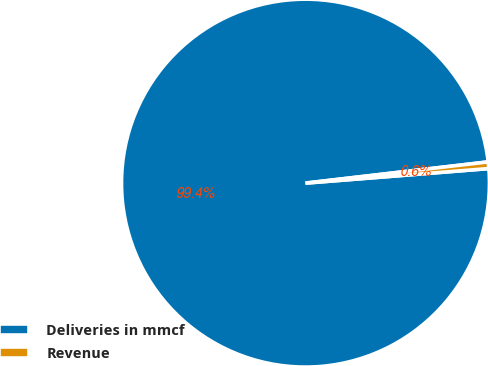Convert chart to OTSL. <chart><loc_0><loc_0><loc_500><loc_500><pie_chart><fcel>Deliveries in mmcf<fcel>Revenue<nl><fcel>99.42%<fcel>0.58%<nl></chart> 